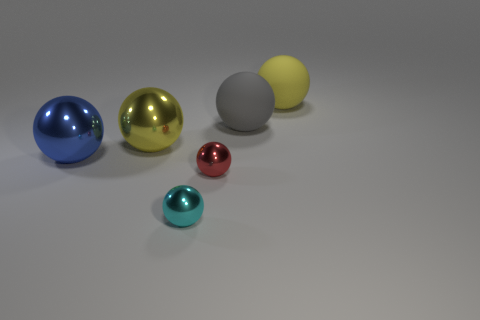Subtract all small metal spheres. How many spheres are left? 4 Subtract all yellow spheres. How many spheres are left? 4 Add 2 big blue metallic things. How many objects exist? 8 Add 2 yellow balls. How many yellow balls exist? 4 Subtract 1 cyan spheres. How many objects are left? 5 Subtract 4 spheres. How many spheres are left? 2 Subtract all red spheres. Subtract all gray cylinders. How many spheres are left? 5 Subtract all gray cylinders. How many yellow spheres are left? 2 Subtract all small metal spheres. Subtract all yellow things. How many objects are left? 2 Add 6 big gray rubber balls. How many big gray rubber balls are left? 7 